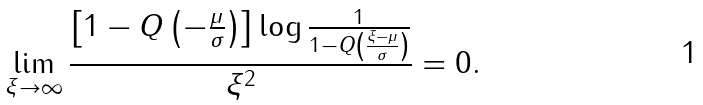Convert formula to latex. <formula><loc_0><loc_0><loc_500><loc_500>\lim _ { \xi \to \infty } \frac { \left [ 1 - Q \left ( - \frac { \mu } { \sigma } \right ) \right ] \log \frac { 1 } { 1 - Q \left ( \frac { \xi - \mu } { \sigma } \right ) } } { \xi ^ { 2 } } = 0 .</formula> 